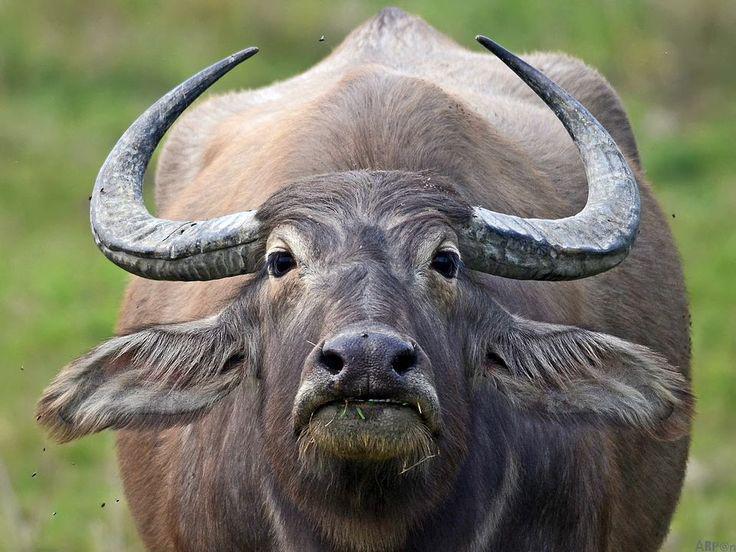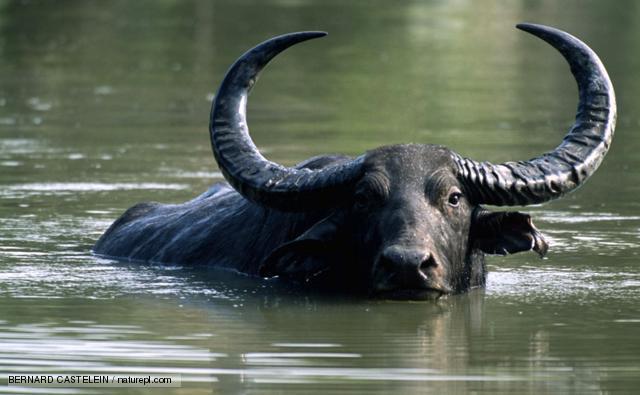The first image is the image on the left, the second image is the image on the right. For the images shown, is this caption "The animal in the image on the left is looking into the camera." true? Answer yes or no. Yes. 